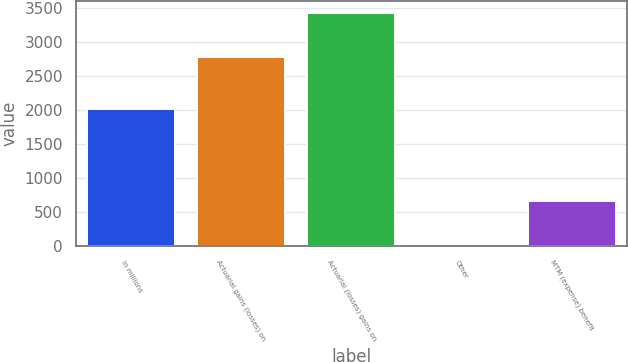<chart> <loc_0><loc_0><loc_500><loc_500><bar_chart><fcel>in millions<fcel>Actuarial gains (losses) on<fcel>Actuarial (losses) gains on<fcel>Other<fcel>MTM (expense) benefit<nl><fcel>2018<fcel>2772<fcel>3426<fcel>1<fcel>655<nl></chart> 